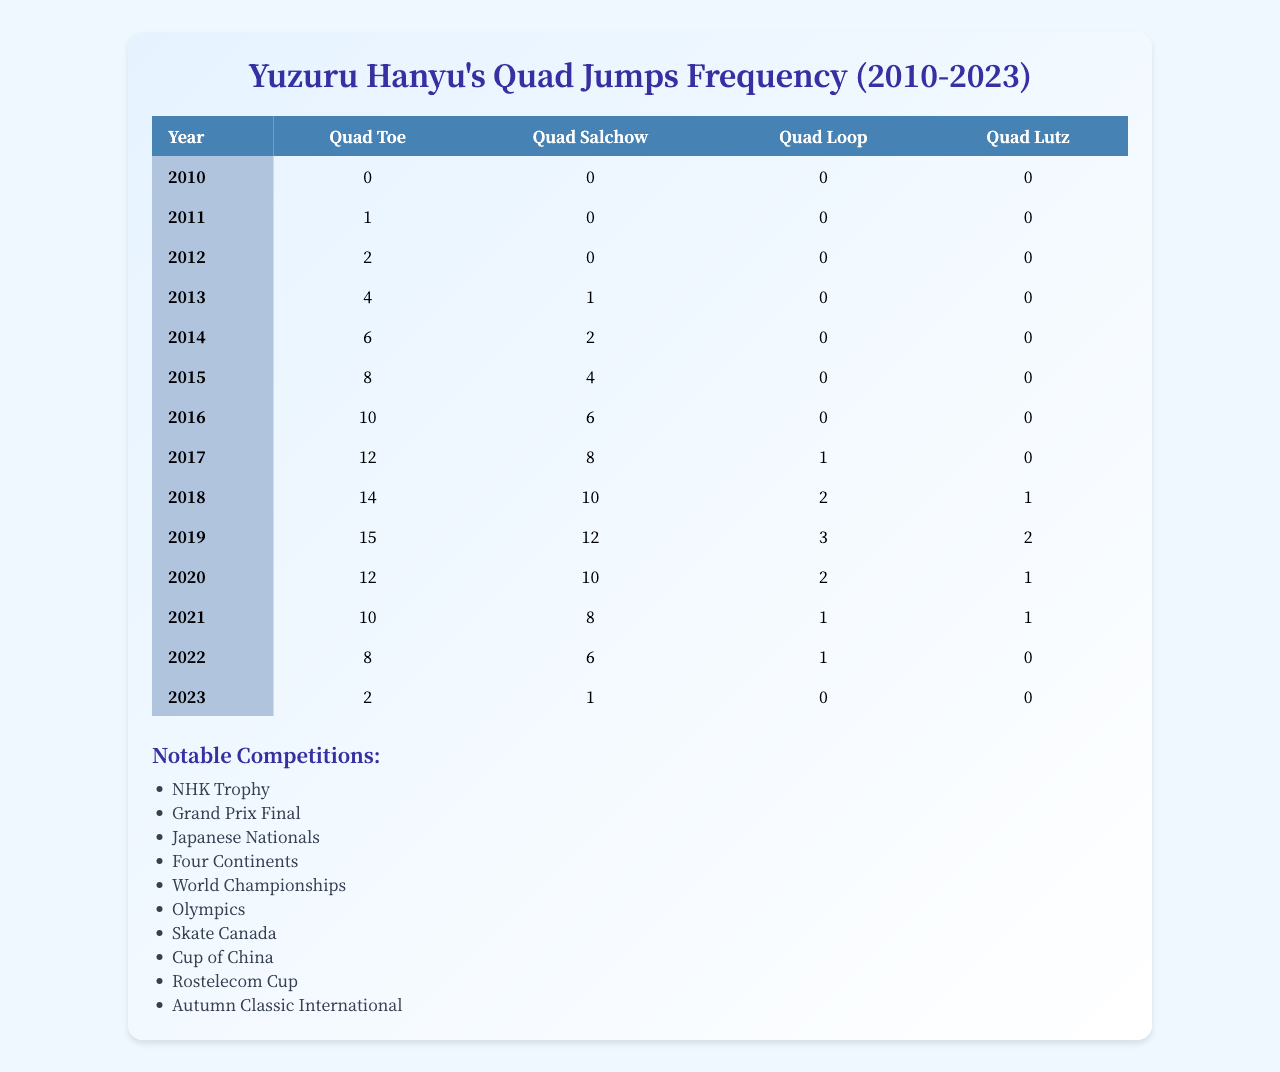What year had the highest frequency of quad toe jumps? By examining the "Quad Toe" column, the highest value is 15, which occurs in 2019.
Answer: 2019 In which year did Yuzuru Hanyu perform quad salchows the most? Looking at the "Quad Salchow" data, the maximum number is 12, noted in the year 2019.
Answer: 2019 What is the total number of quad jumps performed in 2015? Summing the values from all four quad types for 2015: (8 + 4 + 0 + 0) = 12.
Answer: 12 Did Yuzuru Hanyu perform quad loops in 2014? The "Quad Loop" value for 2014 is 0, indicating no quad loops were performed that year.
Answer: No What is the difference in frequency of quad toe jumps between 2014 and 2023? The "Quad Toe" values are 6 for 2014 and 2 for 2023. The difference is 6 - 2 = 4.
Answer: 4 What was the average number of quad salchows from 2010 to 2023? First, sum the values: (0 + 0 + 0 + 1 + 2 + 4 + 6 + 8 + 10 + 12 + 10 + 8 + 6 + 1) = 58. There are 14 years, so the average is 58 / 14 ≈ 4.14.
Answer: Approximately 4.14 Which quad jump had the highest frequency in the year 2018? In 2018, the highest value among quad jumps is for "Quad Toe," which is 14.
Answer: Quad Toe How many quad jumps were performed in total throughout Yuzuru Hanyu's career from 2010 to 2023? Summing all quad types for all years gives: (0+1+2+4+6+8+10+12+14+15+12+10+8+2) + (0+0+0+1+2+4+6+8+10+12+10+8+6+1) + (0+0+0+0+0+0+0+1+2+3+2+1+1+0) + (0+0+0+0+0+0+0+0+1+2+1+1+0+0) = 92.
Answer: 92 In which competitions did Yuzuru Hanyu perform quad jumps? He performed quad jumps in competitions including NHK Trophy, Grand Prix Final, Japanese Nationals, and others listed.
Answer: Multiple competitions What trend can be observed in the frequency of quad jumps from 2010 to 2023? The data shows an increasing trend from 2010 to a peak in 2019, followed by a noticeable decline through 2023.
Answer: Increasing then decreasing trend 